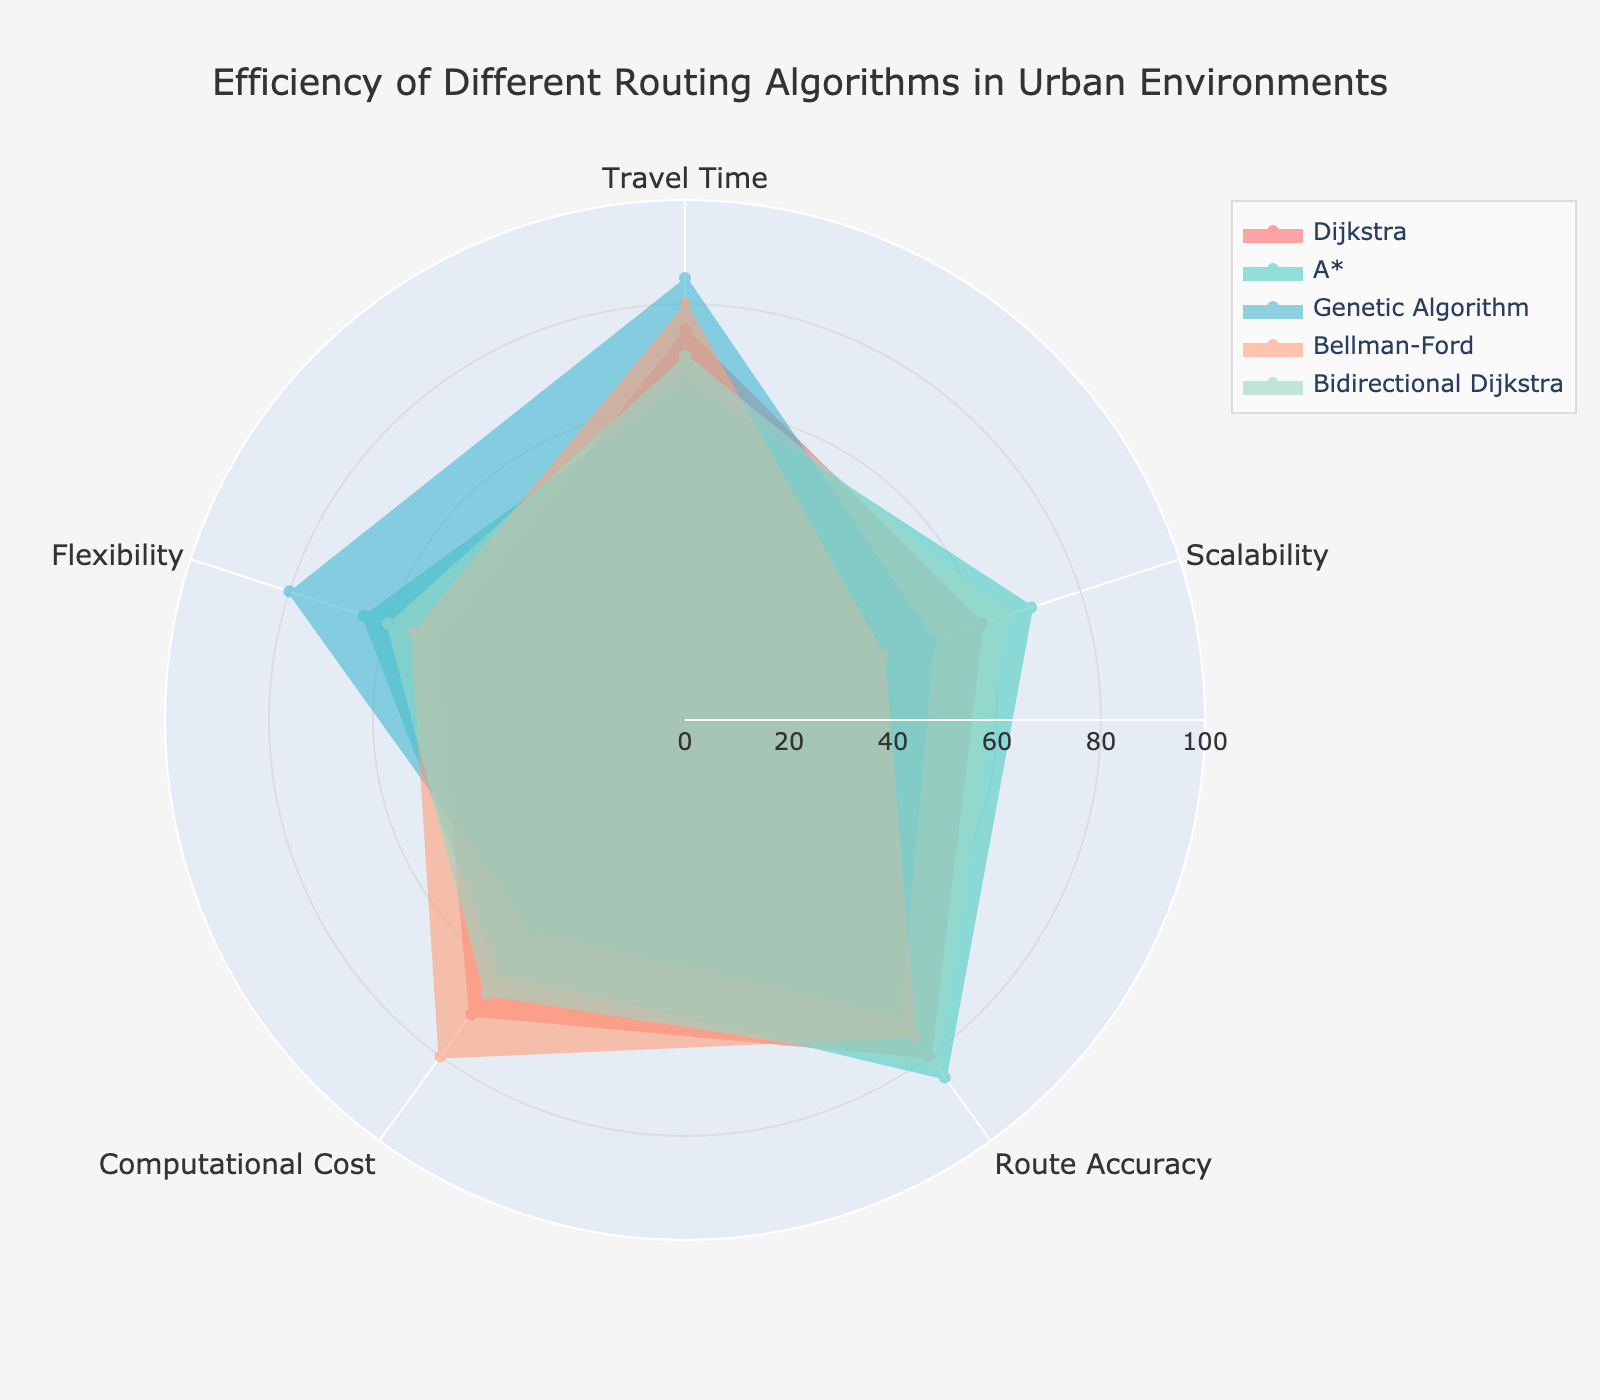What's the title of the figure? The title is usually prominently displayed at the top of the figure. Look for the largest font within the bounding box. In this case, the title is found at the top center.
Answer: Efficiency of Different Routing Algorithms in Urban Environments How many algorithms are compared in the figure? Count the number of unique colors or labels (algorithms) in the legend to determine the number of compared algorithms. There are five different colors, each representing a unique algorithm.
Answer: 5 Which algorithm shows the highest flexibility? Look for the algorithm that extends the furthest from the center towards the 'Flexibility' category. In this chart, the Genetic Algorithm has the longest extension.
Answer: Genetic Algorithm What is the average travel time for the algorithms? Sum the travel times for all the algorithms and divide by the number of algorithms. (75 + 65 + 85 + 80 + 70) / 5 = 75.
Answer: 75 Which algorithm has the lowest computational cost? Identify the algorithm with the smallest extension towards the 'Computational Cost' axis. The Genetic Algorithm has the lowest computational cost (50).
Answer: Genetic Algorithm Which algorithm provides the most balanced performance across all categories? Look for the algorithm whose shape covers a moderately wide area but does not have extreme highs or lows in any single category. Bidirectional Dijkstra shows moderate performance across all metrics.
Answer: Bidirectional Dijkstra Is there an algorithm that is consistently better in scalability and flexibility but not in computational cost? Compare scalability and flexibility across all algorithms and identify any that perform well in these without being good in computational cost. The Genetic Algorithm scores high in flexibility (80) and good in scalability (50) but low in computational cost (50).
Answer: Genetic Algorithm Which two algorithms have the closest travel times? Compare travel times of all algorithms and find the pair with the smallest difference. Dijkstra and Bidirectional Dijkstra are closest, with travel times of 75 and 70, respectively.
Answer: Dijkstra and Bidirectional Dijkstra Which algorithm has the highest route accuracy? Find the algorithm that extends the furthest towards the 'Route Accuracy' category. A* has the highest route accuracy (85).
Answer: A* By how much does Bellman-Ford outperform Dijkstra in computational cost? Identify the computational costs of Bellman-Ford and Dijkstra and calculate the difference. Bellman-Ford (80) - Dijkstra (70) = 10.
Answer: 10 